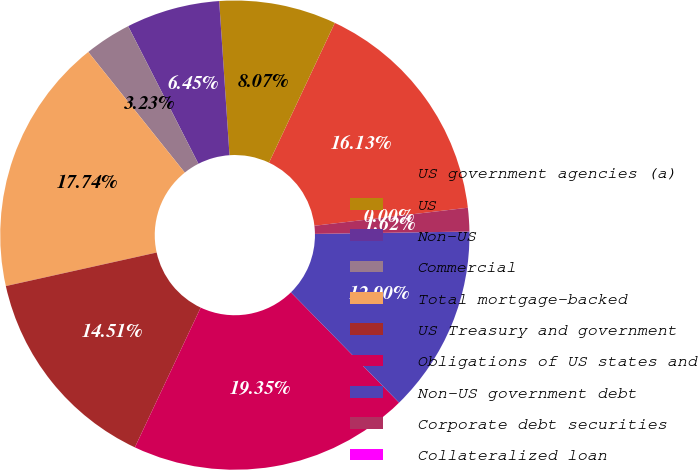Convert chart. <chart><loc_0><loc_0><loc_500><loc_500><pie_chart><fcel>US government agencies (a)<fcel>US<fcel>Non-US<fcel>Commercial<fcel>Total mortgage-backed<fcel>US Treasury and government<fcel>Obligations of US states and<fcel>Non-US government debt<fcel>Corporate debt securities<fcel>Collateralized loan<nl><fcel>16.13%<fcel>8.07%<fcel>6.45%<fcel>3.23%<fcel>17.74%<fcel>14.51%<fcel>19.35%<fcel>12.9%<fcel>1.62%<fcel>0.0%<nl></chart> 